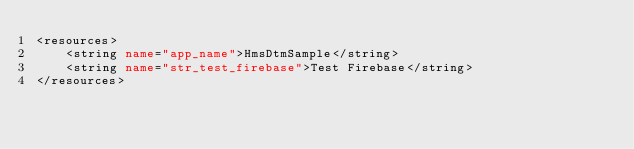<code> <loc_0><loc_0><loc_500><loc_500><_XML_><resources>
    <string name="app_name">HmsDtmSample</string>
    <string name="str_test_firebase">Test Firebase</string>
</resources></code> 